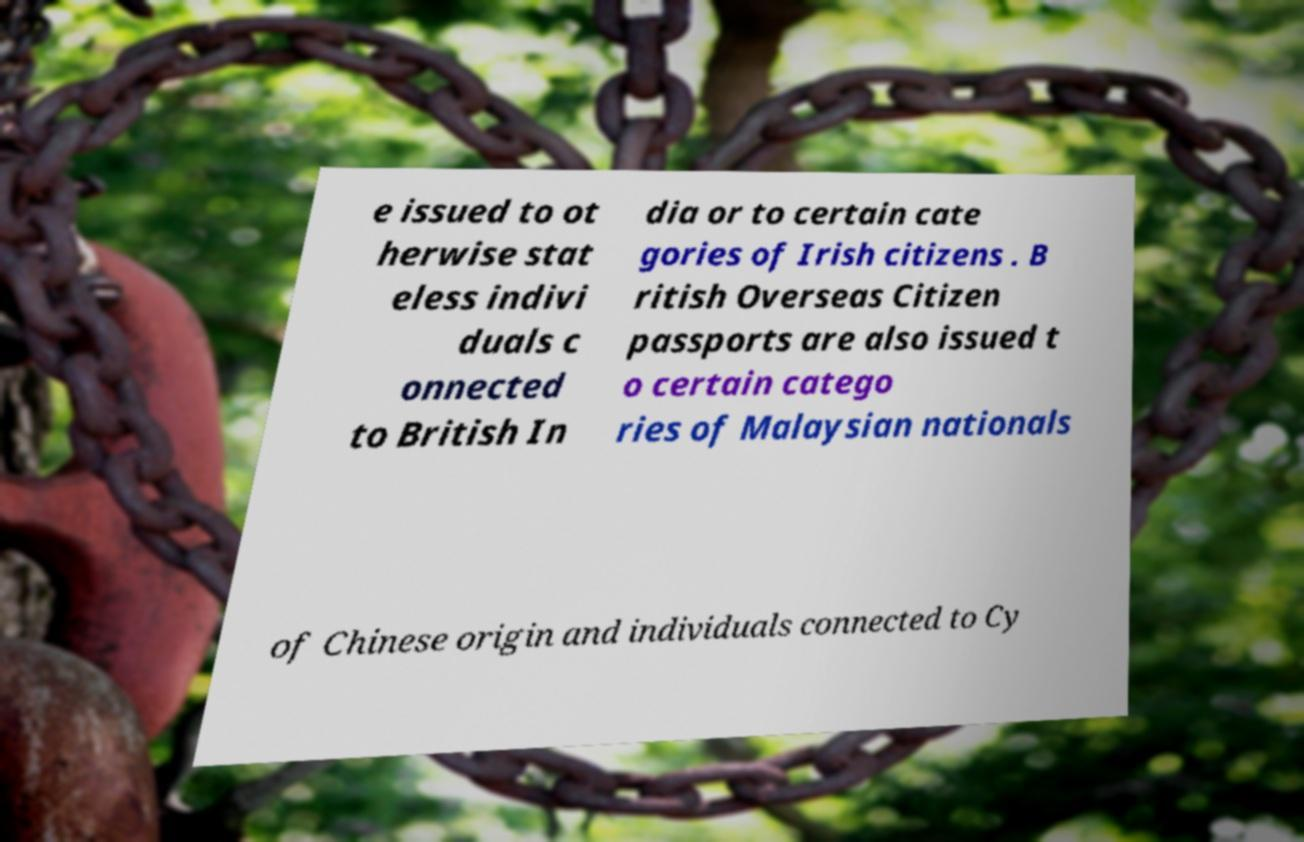For documentation purposes, I need the text within this image transcribed. Could you provide that? e issued to ot herwise stat eless indivi duals c onnected to British In dia or to certain cate gories of Irish citizens . B ritish Overseas Citizen passports are also issued t o certain catego ries of Malaysian nationals of Chinese origin and individuals connected to Cy 